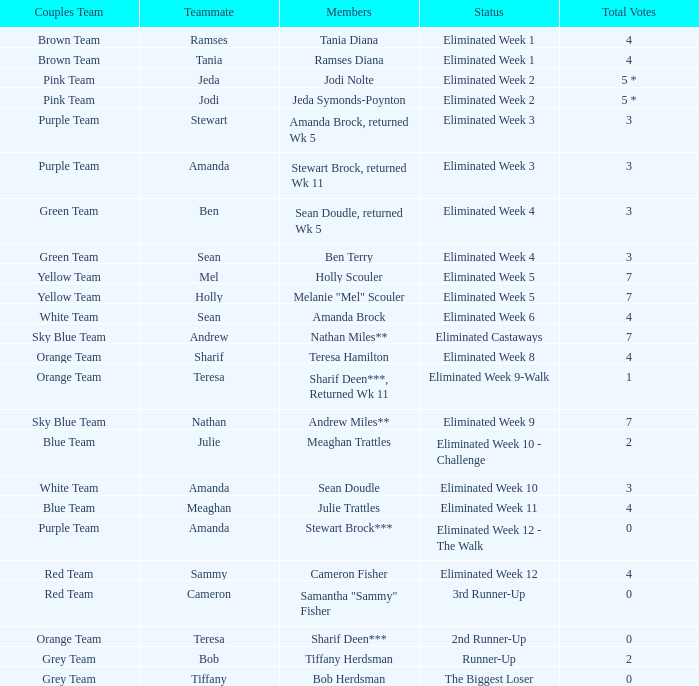What was Holly Scouler's total votes 7.0. 